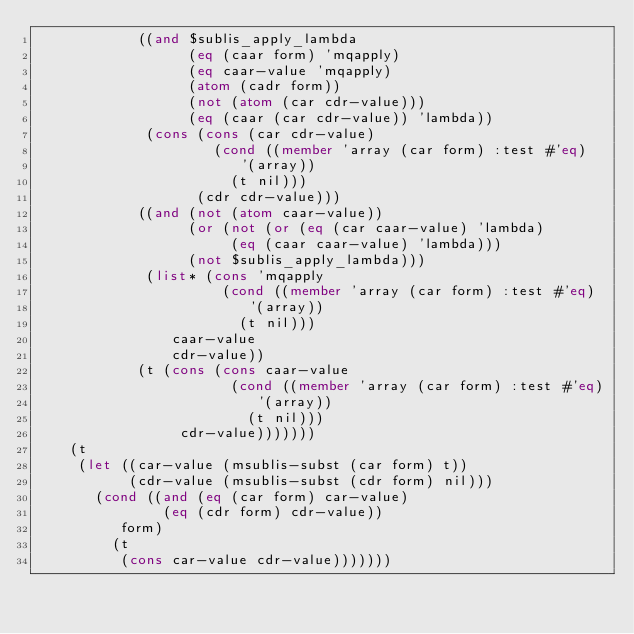<code> <loc_0><loc_0><loc_500><loc_500><_Lisp_>			((and $sublis_apply_lambda
			      (eq (caar form) 'mqapply)
			      (eq caar-value 'mqapply)
			      (atom (cadr form))
			      (not (atom (car cdr-value)))
			      (eq (caar (car cdr-value)) 'lambda))
			 (cons (cons (car cdr-value)
				     (cond ((member 'array (car form) :test #'eq)
					    '(array))
					   (t nil)))
			       (cdr cdr-value)))
			((and (not (atom caar-value))
			      (or (not (or (eq (car caar-value) 'lambda)
					   (eq (caar caar-value) 'lambda)))
				  (not $sublis_apply_lambda)))
			 (list* (cons 'mqapply
				      (cond ((member 'array (car form) :test #'eq)
					     '(array))
					    (t nil)))
				caar-value
				cdr-value))
			(t (cons (cons caar-value
				       (cond ((member 'array (car form) :test #'eq)
					      '(array))
					     (t nil)))
				 cdr-value)))))))
	(t
	 (let ((car-value (msublis-subst (car form) t))
	       (cdr-value (msublis-subst (cdr form) nil)))
	   (cond ((and (eq (car form) car-value)
		       (eq (cdr form) cdr-value))
		  form)
		 (t
		  (cons car-value cdr-value)))))))
</code> 